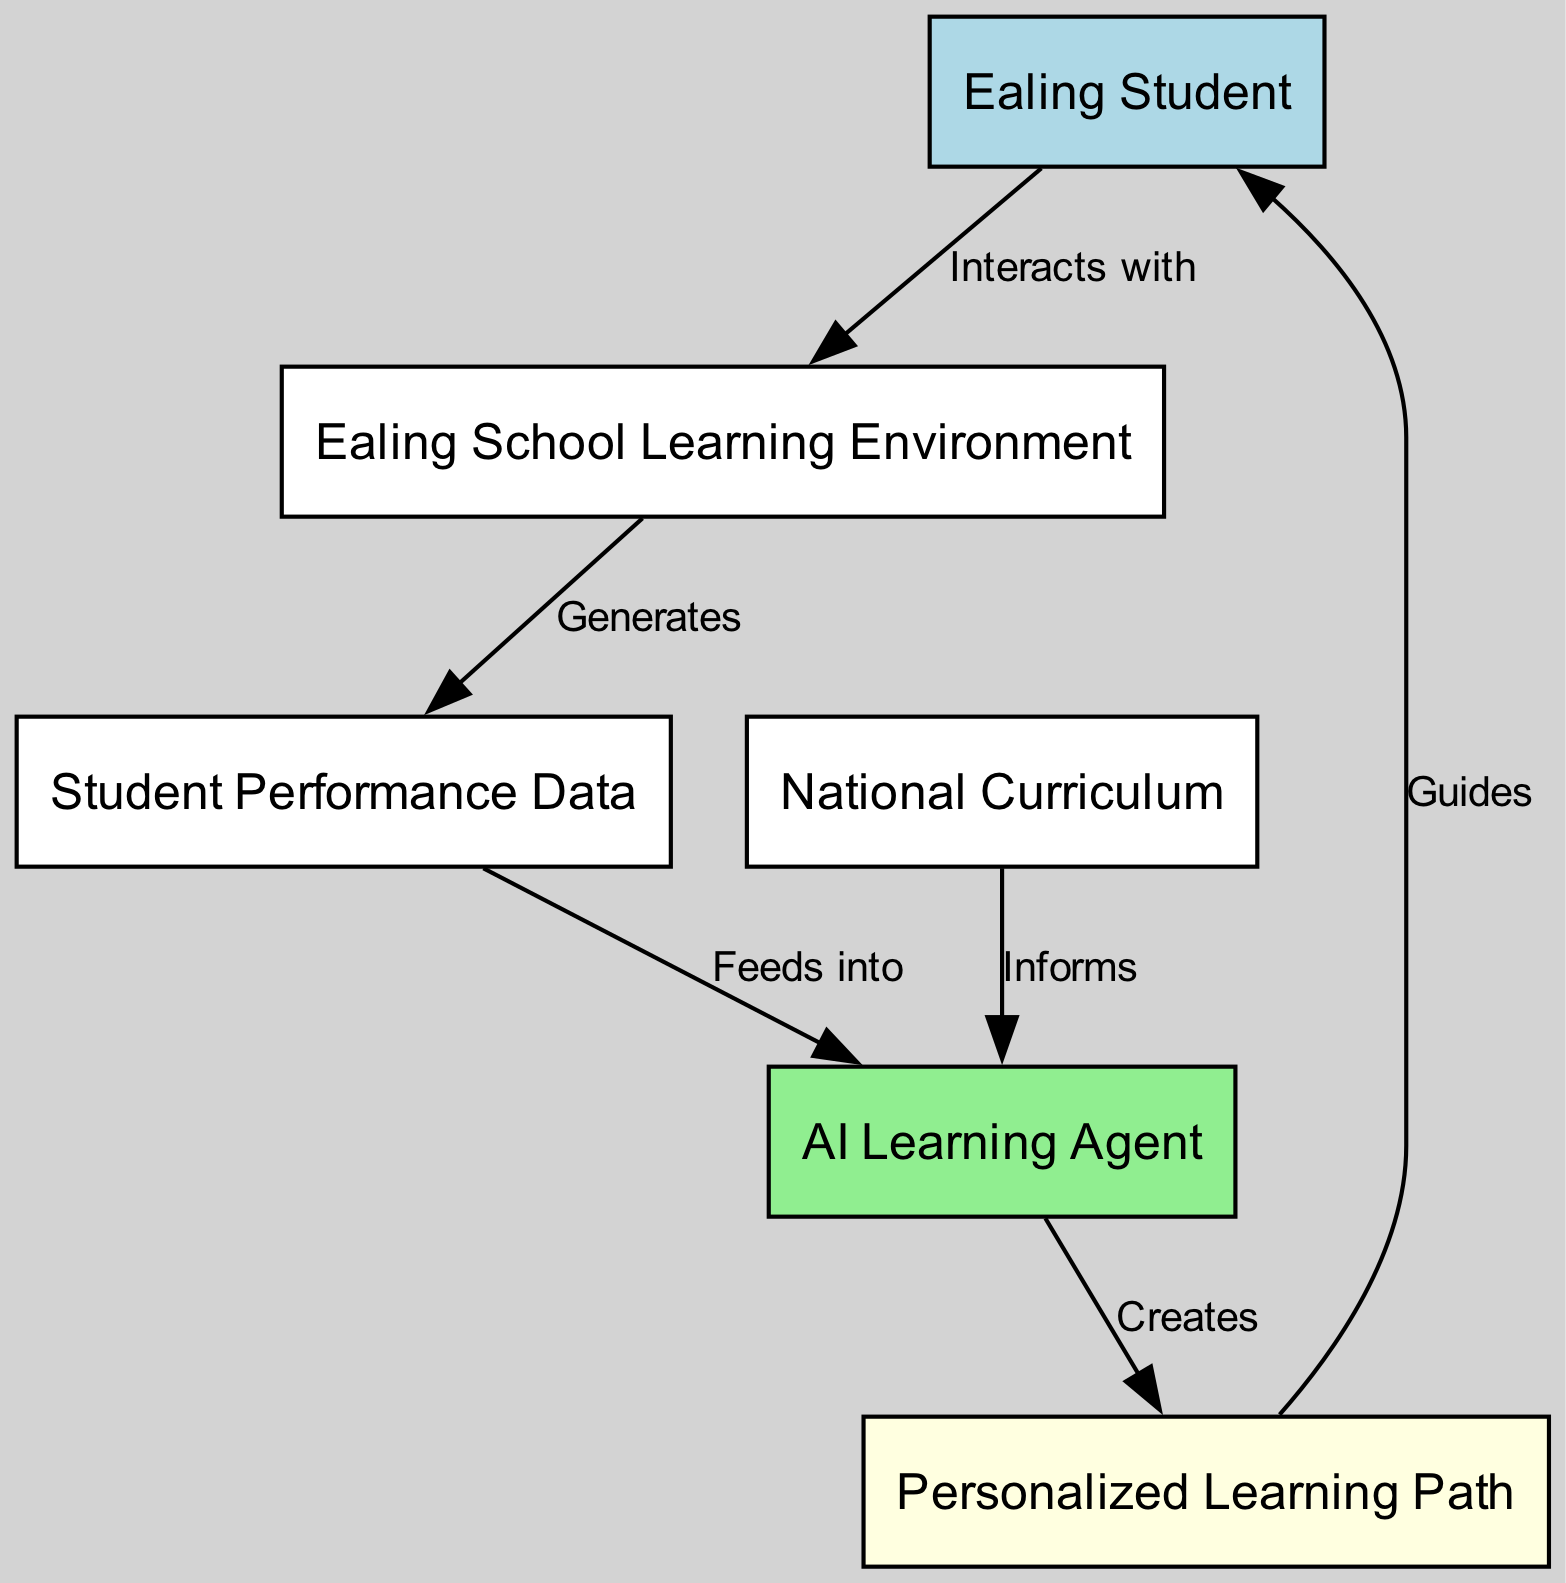What is the total number of nodes in the diagram? The diagram has a total of six nodes: Ealing Student, Ealing School Learning Environment, AI Learning Agent, National Curriculum, Student Performance Data, and Personalized Learning Path.
Answer: 6 Which node guides the student? The node that guides the student is the Personalized Learning Path, as indicated by the edge directed from this node to Ealing Student with the label "Guides."
Answer: Personalized Learning Path What relationship does the AI Learning Agent have with the National Curriculum? The relationship is informative, as the AI Learning Agent is informed by the National Curriculum, shown by the edge directed from National Curriculum to AI Learning Agent with the label "Informs."
Answer: Informs How many edges are there connecting the nodes? There are five edges connecting the nodes, illustrating the relationships and interactions among them as indicated in the diagram.
Answer: 5 What data feeds into the AI Learning Agent? The data that feeds into the AI Learning Agent is the Student Performance Data, as indicated by the edge going from this node to the AI Learning Agent with the label "Feeds into."
Answer: Student Performance Data What does the AI Learning Agent create based on the input? The AI Learning Agent creates a Personalized Learning Path for students, which is indicated by the edge directed from the AI Learning Agent to Personalized Learning Path labeled with "Creates."
Answer: Personalized Learning Path What does the Ealing School Learning Environment generate? The Ealing School Learning Environment generates Student Performance Data as indicated by the edge from this node to Student Performance Data with the label "Generates."
Answer: Student Performance Data What is the role of the Ealing Student in this diagram? The Ealing Student interacts with the Ealing School Learning Environment, as shown by the edge labeled "Interacts with."
Answer: Interacts with 